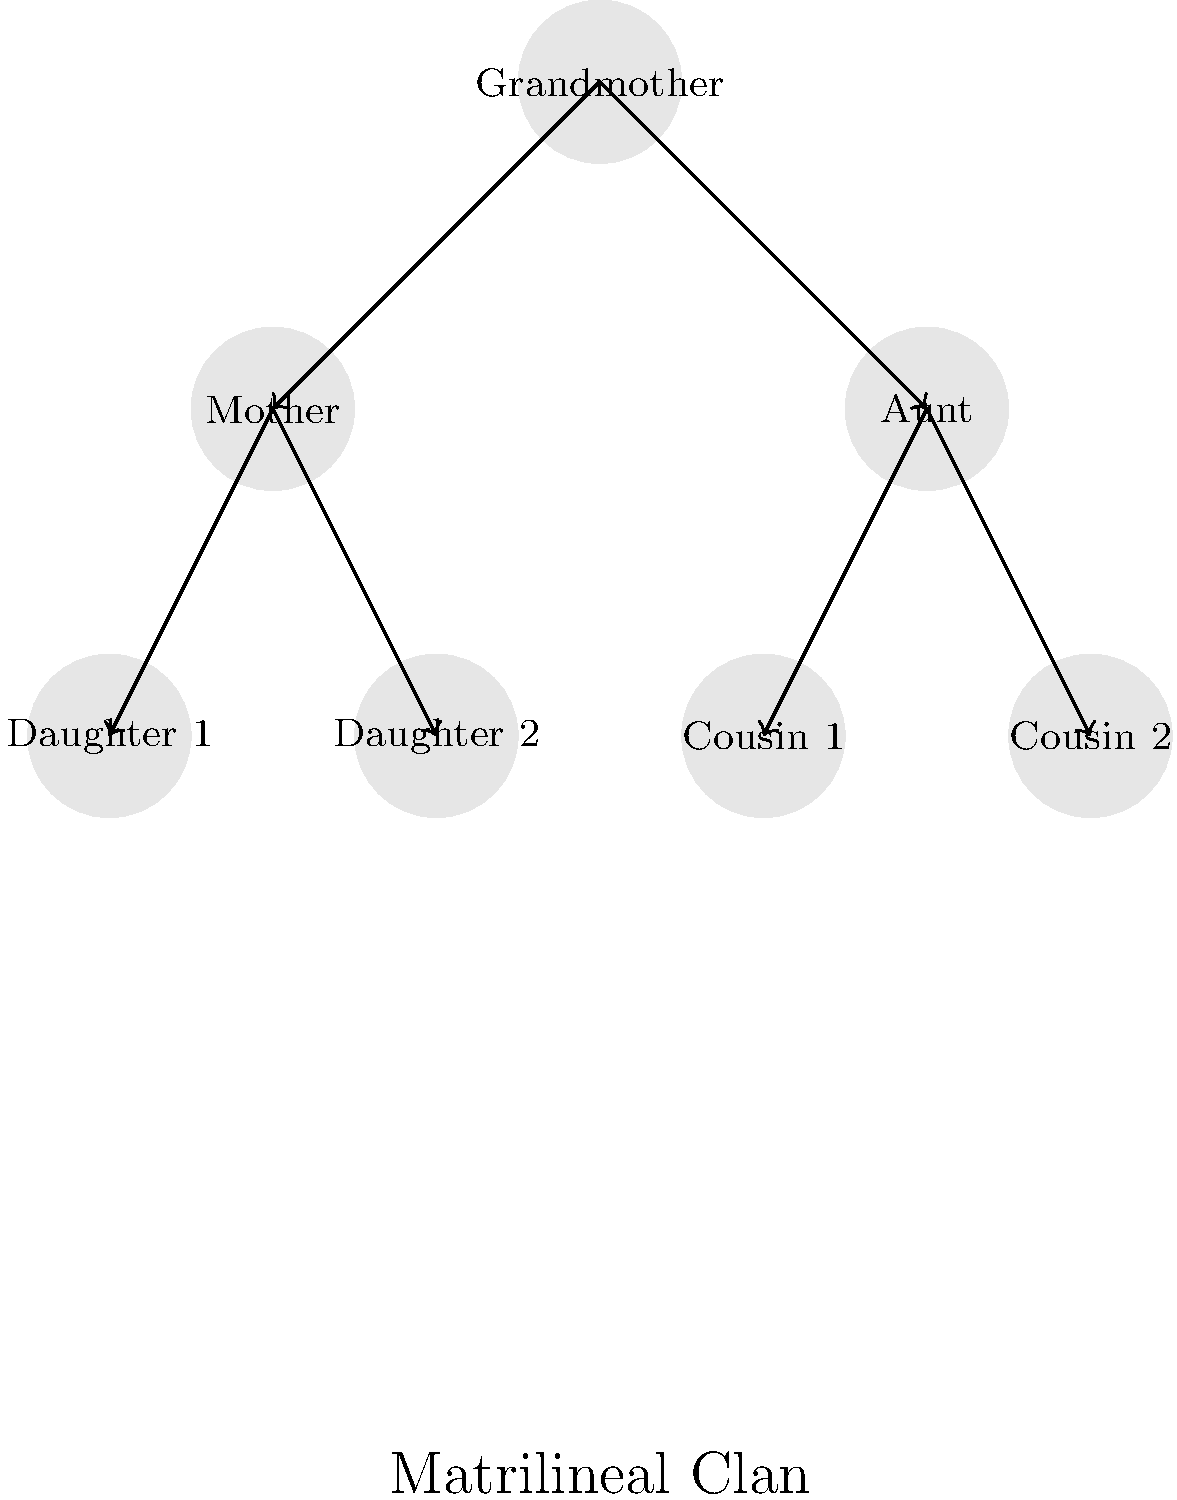In the Navajo matrilineal clan system represented by this family tree diagram, how many generations are shown, and what is the significance of this structure in Navajo culture? To answer this question, let's analyze the diagram step-by-step:

1. Count the generations:
   - The topmost figure represents the grandmother (1st generation)
   - The next level shows the mother and aunt (2nd generation)
   - The bottom level shows daughters and cousins (3rd generation)
   Thus, there are 3 generations shown in the diagram.

2. Understand the matrilineal structure:
   - The arrows point from older generations to younger ones
   - All connections flow through female family members

3. Significance in Navajo culture:
   a) Identity: Clan membership is passed down through the mother's line
   b) Kinship: Defines familial relationships and social structure
   c) Marriage: Helps avoid clan intermarriage, which is taboo
   d) Cultural continuity: Preserves traditional Navajo social organization
   e) Spiritual connection: Links individuals to their ancestors and creation stories

4. The diagram emphasizes:
   - The central role of women in Navajo society
   - The importance of maternal lineage in determining clan affiliation
   - The multi-generational nature of clan identity

In Navajo culture, this matrilineal system is crucial for maintaining social harmony, preserving cultural heritage, and guiding personal interactions within the community.
Answer: 3 generations; defines identity, kinship, and cultural continuity through maternal lineage 